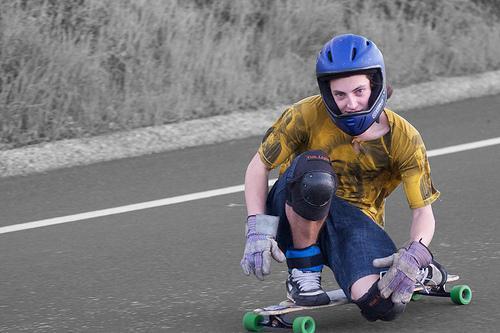How many people are in the photo?
Give a very brief answer. 1. 